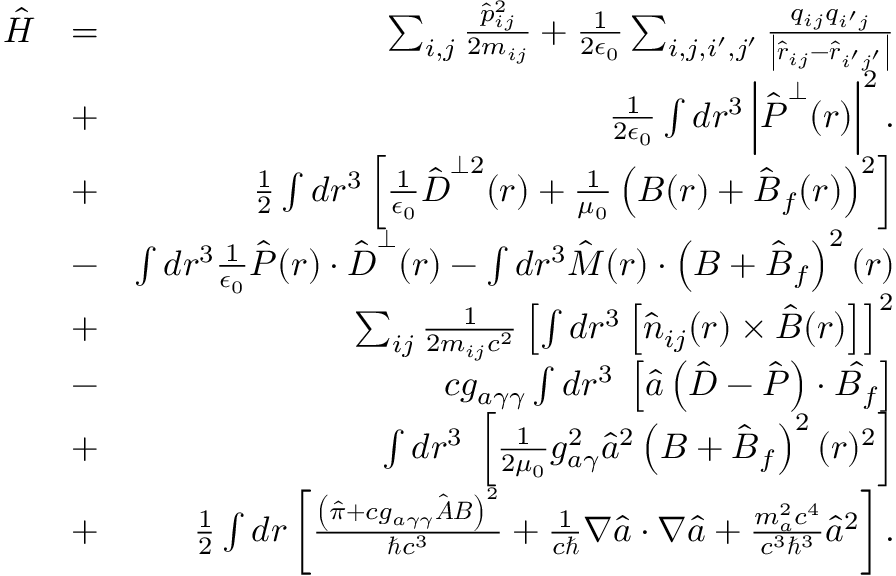Convert formula to latex. <formula><loc_0><loc_0><loc_500><loc_500>\begin{array} { r l r } { \hat { H } } & { = } & { \sum _ { i , j } \frac { \hat { p } _ { i j } ^ { 2 } } { 2 m _ { i j } } + \frac { 1 } { 2 \epsilon _ { 0 } } \sum _ { i , j , i ^ { \prime } , j ^ { \prime } } \frac { q _ { i j } q _ { i ^ { \prime } j } } { \left | \hat { \boldsymbol r } _ { i j } - \hat { \boldsymbol r } _ { i ^ { \prime } j ^ { \prime } } \right | } } \\ & { + } & { \frac { 1 } { 2 \epsilon _ { 0 } } \int d \boldsymbol r ^ { 3 } \left | \hat { \boldsymbol P } ^ { \perp } ( \boldsymbol r ) \right | ^ { 2 } . } \\ & { + } & { \frac { 1 } { 2 } \int d \boldsymbol r ^ { 3 } \left [ \frac { 1 } { \epsilon _ { 0 } } \hat { \boldsymbol D } ^ { \perp 2 } ( \boldsymbol r ) + \frac { 1 } { \mu _ { 0 } } \left ( { \boldsymbol B } ( \boldsymbol r ) + \hat { \boldsymbol B } _ { f } ( \boldsymbol r ) \right ) ^ { 2 } \right ] } \\ & { - } & { \int d \boldsymbol r ^ { 3 } \frac { 1 } { \epsilon _ { 0 } } \hat { \boldsymbol P } ( \boldsymbol r ) \cdot \hat { \boldsymbol D } ^ { \perp } ( \boldsymbol r ) - \int d \boldsymbol r ^ { 3 } \hat { \boldsymbol M } ( \boldsymbol r ) \cdot \left ( { \boldsymbol B } + \hat { \boldsymbol B } _ { f } \right ) ^ { 2 } ( \boldsymbol r ) } \\ & { + } & { \sum _ { i j } \frac { 1 } { 2 m _ { i j } c ^ { 2 } } \left [ \int d \boldsymbol r ^ { 3 } \left [ \hat { n } _ { i j } ( \boldsymbol r ) \times \hat { B } ( \boldsymbol r ) \right ] \right ] ^ { 2 } } \\ & { - } & { c g _ { a \gamma \gamma } \int d \boldsymbol r ^ { 3 } \, \left [ \hat { a } \left ( \hat { \boldsymbol D } - \hat { \boldsymbol P } \right ) \cdot \hat { \boldsymbol B _ { f } } \right ] } \\ & { + } & { \int d \boldsymbol r ^ { 3 } \, \left [ \frac { 1 } { 2 \mu _ { 0 } } g _ { a \gamma } ^ { 2 } \hat { a } ^ { 2 } \left ( { \boldsymbol B } + \hat { \boldsymbol B } _ { f } \right ) ^ { 2 } ( \boldsymbol r ) ^ { 2 } \right ] } \\ & { + } & { \frac { 1 } { 2 } \int d \boldsymbol r \left [ \frac { \left ( \hat { \pi } + c g _ { a \gamma \gamma } \hat { \boldsymbol A } { \boldsymbol B } \right ) ^ { 2 } } { \hbar { c } ^ { 3 } } + \frac { 1 } { c } \boldsymbol \nabla \hat { a } \cdot \boldsymbol \nabla \hat { a } + \frac { m _ { a } ^ { 2 } c ^ { 4 } } { c ^ { 3 } \hbar { ^ } { 3 } } \hat { a } ^ { 2 } \right ] . } \end{array}</formula> 